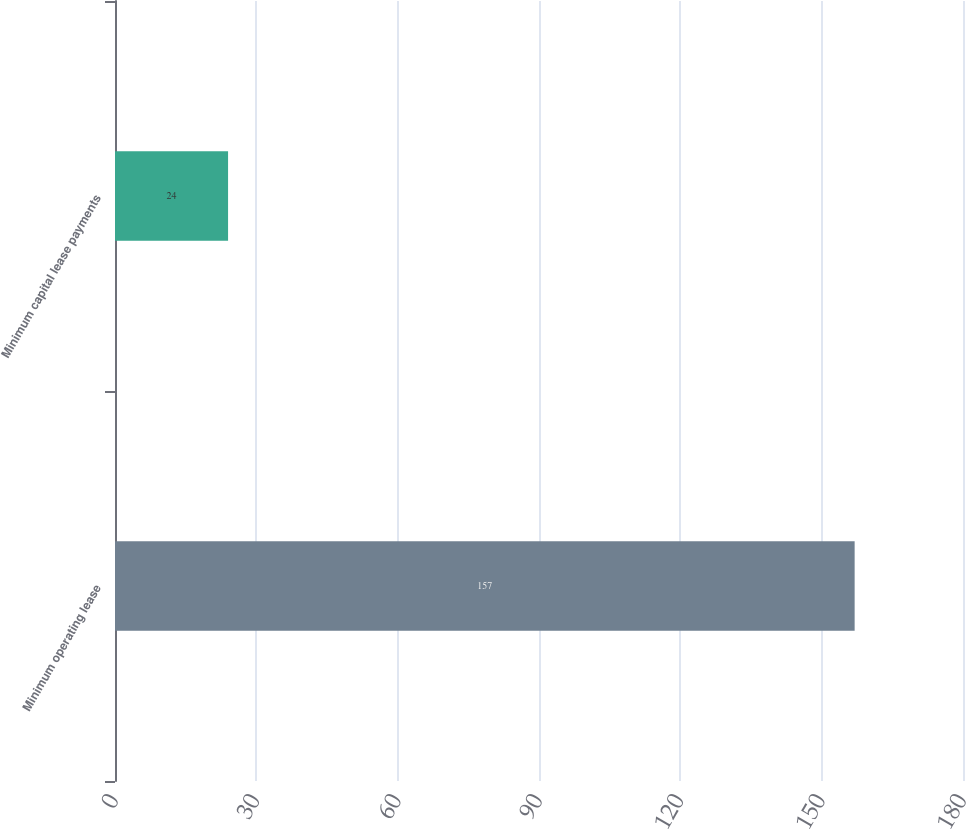<chart> <loc_0><loc_0><loc_500><loc_500><bar_chart><fcel>Minimum operating lease<fcel>Minimum capital lease payments<nl><fcel>157<fcel>24<nl></chart> 